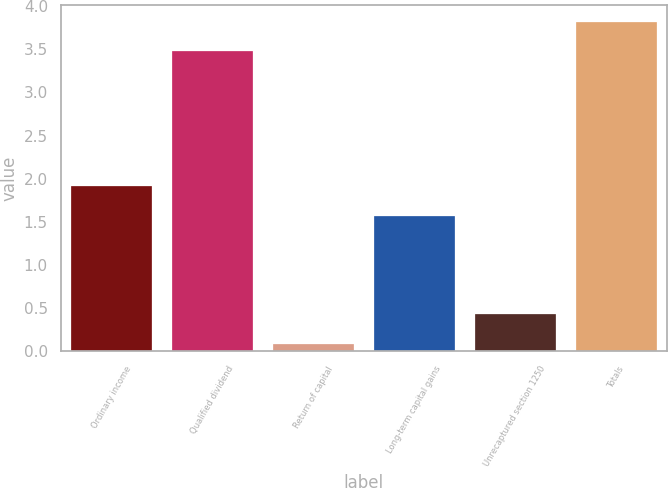Convert chart to OTSL. <chart><loc_0><loc_0><loc_500><loc_500><bar_chart><fcel>Ordinary income<fcel>Qualified dividend<fcel>Return of capital<fcel>Long-term capital gains<fcel>Unrecaptured section 1250<fcel>Totals<nl><fcel>1.91<fcel>3.48<fcel>0.09<fcel>1.57<fcel>0.43<fcel>3.82<nl></chart> 